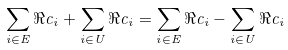Convert formula to latex. <formula><loc_0><loc_0><loc_500><loc_500>\sum _ { i \in E } \Re c _ { i } + \sum _ { i \in U } \Re c _ { i } = \sum _ { i \in E } \Re c _ { i } - \sum _ { i \in U } \Re c _ { i }</formula> 